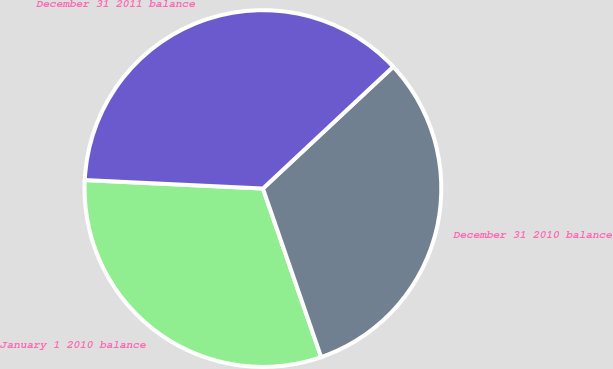Convert chart. <chart><loc_0><loc_0><loc_500><loc_500><pie_chart><fcel>January 1 2010 balance<fcel>December 31 2010 balance<fcel>December 31 2011 balance<nl><fcel>31.05%<fcel>31.67%<fcel>37.28%<nl></chart> 